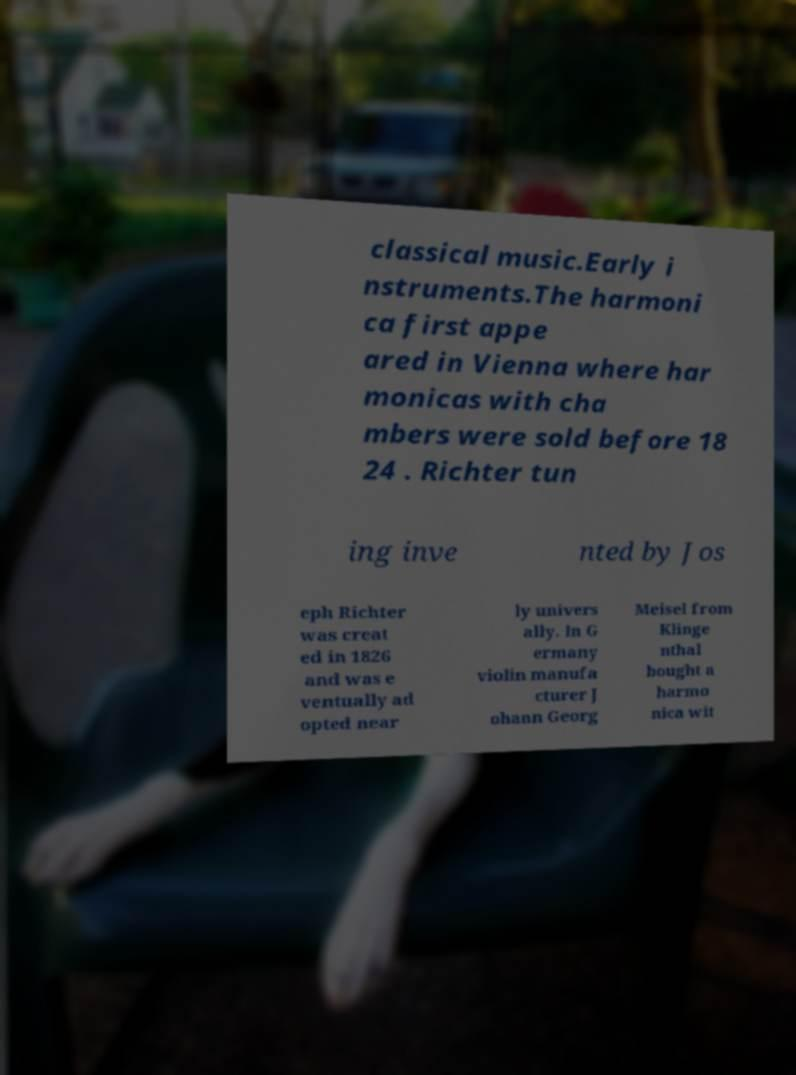Could you assist in decoding the text presented in this image and type it out clearly? classical music.Early i nstruments.The harmoni ca first appe ared in Vienna where har monicas with cha mbers were sold before 18 24 . Richter tun ing inve nted by Jos eph Richter was creat ed in 1826 and was e ventually ad opted near ly univers ally. In G ermany violin manufa cturer J ohann Georg Meisel from Klinge nthal bought a harmo nica wit 